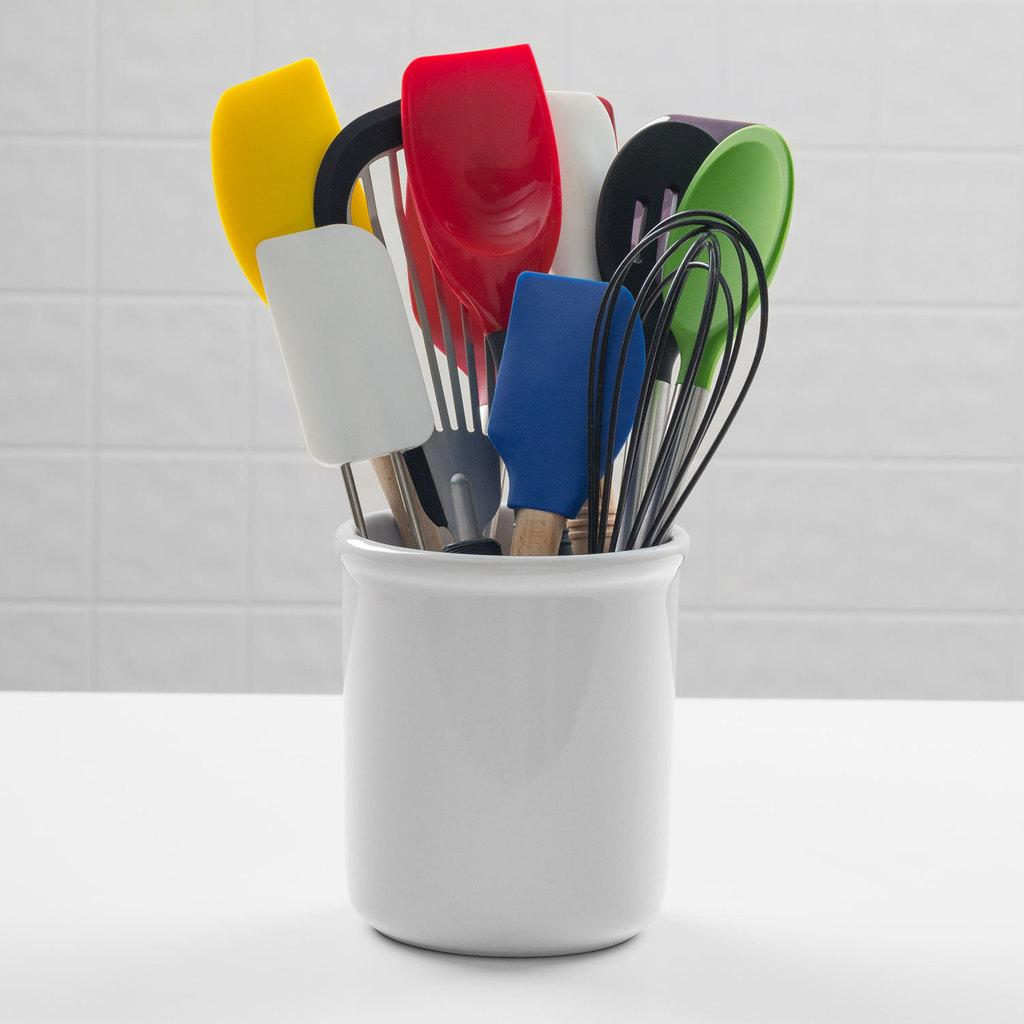What is the main object in the image? There is a white jar in the image. What is inside the jar? The jar contains spoons and other objects. What is the color of the background in the image? The background of the image is white. What type of juice can be seen in the jar in the image? There is no juice present in the jar; it contains spoons and other objects. What nerve is visible in the image? There are no nerves visible in the image; it features a white jar with spoons and other objects. 